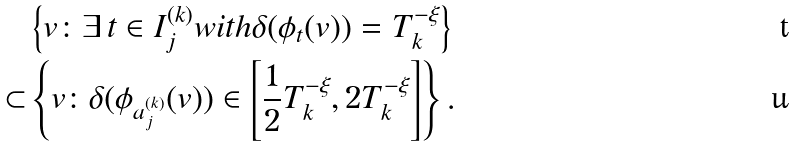<formula> <loc_0><loc_0><loc_500><loc_500>& \left \{ v \colon \exists \, t \in I _ { j } ^ { ( k ) } w i t h \delta ( \phi _ { t } ( v ) ) = T _ { k } ^ { - \xi } \right \} \\ \subset & \left \{ v \colon \delta ( \phi _ { a _ { j } ^ { ( k ) } } ( v ) ) \in \left [ \frac { 1 } { 2 } T _ { k } ^ { - \xi } , 2 T _ { k } ^ { - \xi } \right ] \right \} .</formula> 